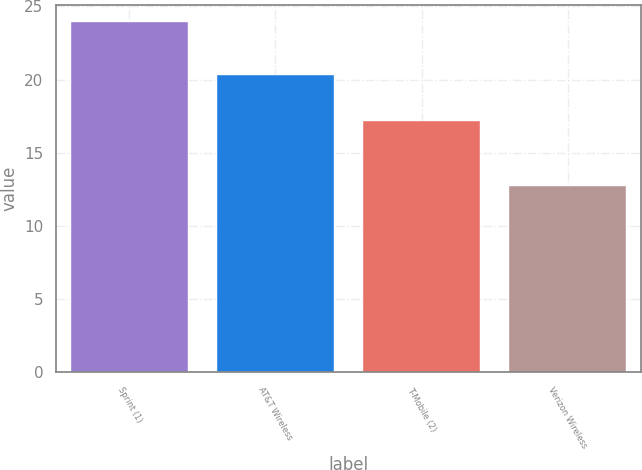<chart> <loc_0><loc_0><loc_500><loc_500><bar_chart><fcel>Sprint (1)<fcel>AT&T Wireless<fcel>T-Mobile (2)<fcel>Verizon Wireless<nl><fcel>23.9<fcel>20.3<fcel>17.2<fcel>12.7<nl></chart> 